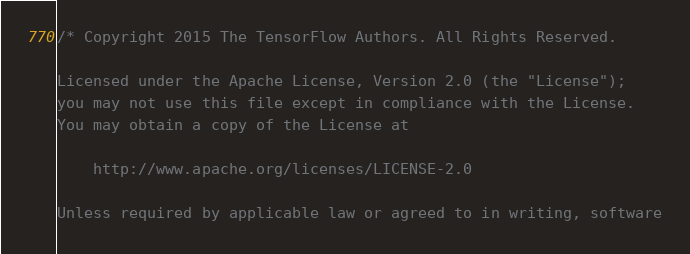<code> <loc_0><loc_0><loc_500><loc_500><_C_>/* Copyright 2015 The TensorFlow Authors. All Rights Reserved.

Licensed under the Apache License, Version 2.0 (the "License");
you may not use this file except in compliance with the License.
You may obtain a copy of the License at

    http://www.apache.org/licenses/LICENSE-2.0

Unless required by applicable law or agreed to in writing, software</code> 